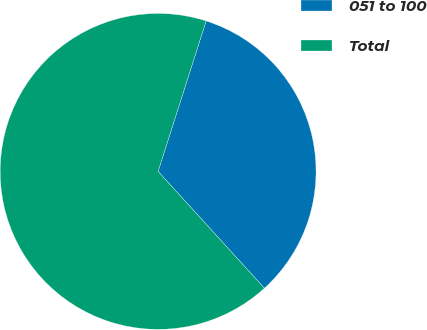Convert chart. <chart><loc_0><loc_0><loc_500><loc_500><pie_chart><fcel>051 to 100<fcel>Total<nl><fcel>33.33%<fcel>66.67%<nl></chart> 